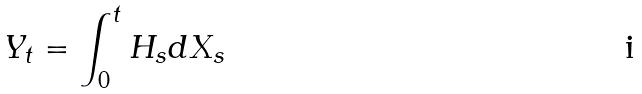<formula> <loc_0><loc_0><loc_500><loc_500>Y _ { t } = \int _ { 0 } ^ { t } H _ { s } d X _ { s }</formula> 